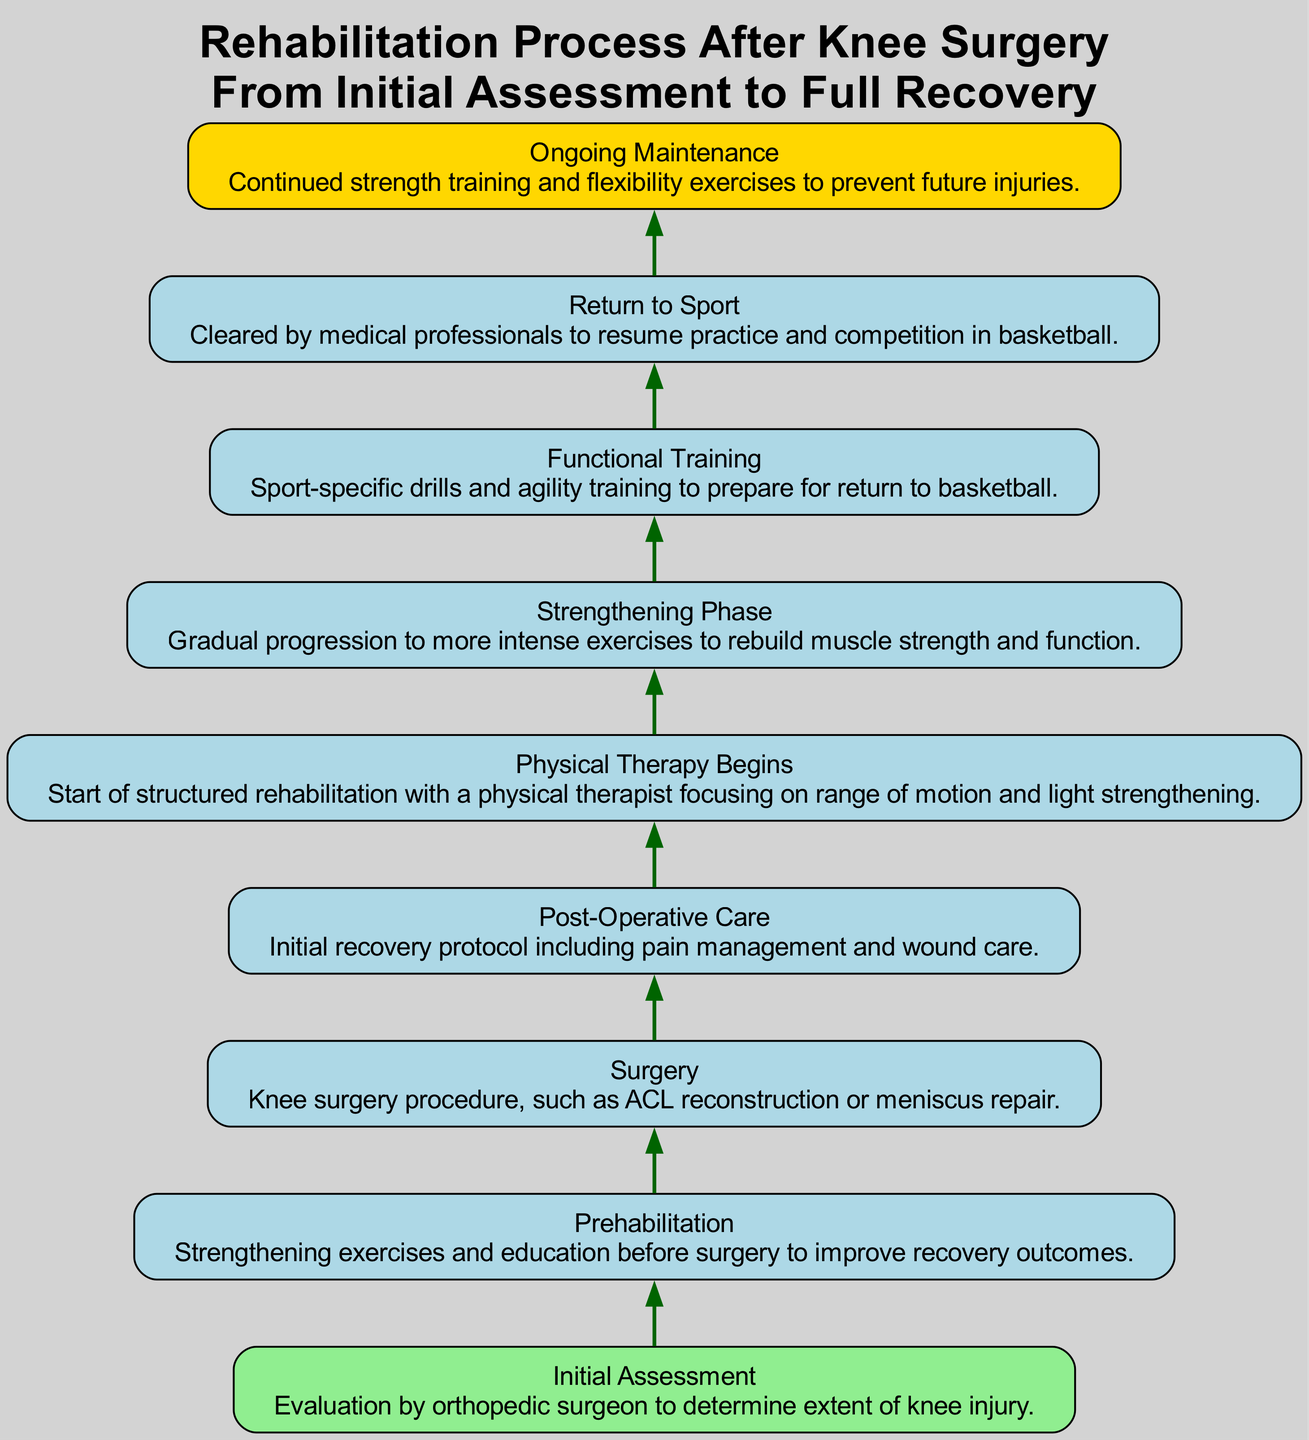What is the first step in the rehabilitation process? The first step is represented by the top node in the diagram, which is labeled "Initial Assessment." This is the starting point of the flow chart, indicating that it is the initial action taken.
Answer: Initial Assessment How many steps are there in total from initial assessment to ongoing maintenance? By examining the diagram, we can count the number of unique nodes, which represent individual steps in the process. There are nine nodes in total, from Initial Assessment to Ongoing Maintenance.
Answer: 9 What is the purpose of the surgery step? Looking at the node labeled "Surgery" in the diagram, it describes that this step involves a knee surgery procedure, such as ACL reconstruction or meniscus repair. This explains the role of this step in the recovery process.
Answer: Knee surgery procedure What step follows post-operative care? By analyzing the flow from the "Post-Operative Care" node, we see that the next step in the process is "Physical Therapy Begins." This shows the progression in recovery after initial care post-surgery.
Answer: Physical Therapy Begins Which step is primarily focused on sport-specific drills? The node titled "Functional Training" is where sport-specific drills and agility training occur. It is dedicated to preparing the athlete for a return to their sport, highlighting its focus on basketball-specific exercises.
Answer: Functional Training What color is the node for ongoing maintenance? The node for "Ongoing Maintenance" is colored gold according to the specified customization in the diagram. This unique color visually distinguishes it from other steps in the flow chart.
Answer: Gold What is the relationship between prehabilitation and surgery? "Prehabilitation" occurs before the "Surgery" node in the flow chart, indicating that strengthening exercises and education are performed prior to the actual surgical procedure, enhancing recovery outcomes.
Answer: Prehabilitation precedes Surgery What phase comes immediately after physical therapy begins? Following the "Physical Therapy Begins" step in the diagram, the next phase is the "Strengthening Phase," which indicates a progression to more intense exercises focused on rebuilding muscle strength.
Answer: Strengthening Phase What ongoing practice is represented at the last step of the process? The final step in the flow chart is "Ongoing Maintenance," suggesting that it is a continuous practice involving strength training and flexibility exercises to prevent future injuries after full recovery.
Answer: Ongoing Maintenance 